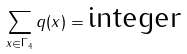<formula> <loc_0><loc_0><loc_500><loc_500>\sum _ { x \in \Gamma _ { 4 } } q ( x ) = \text {integer}</formula> 